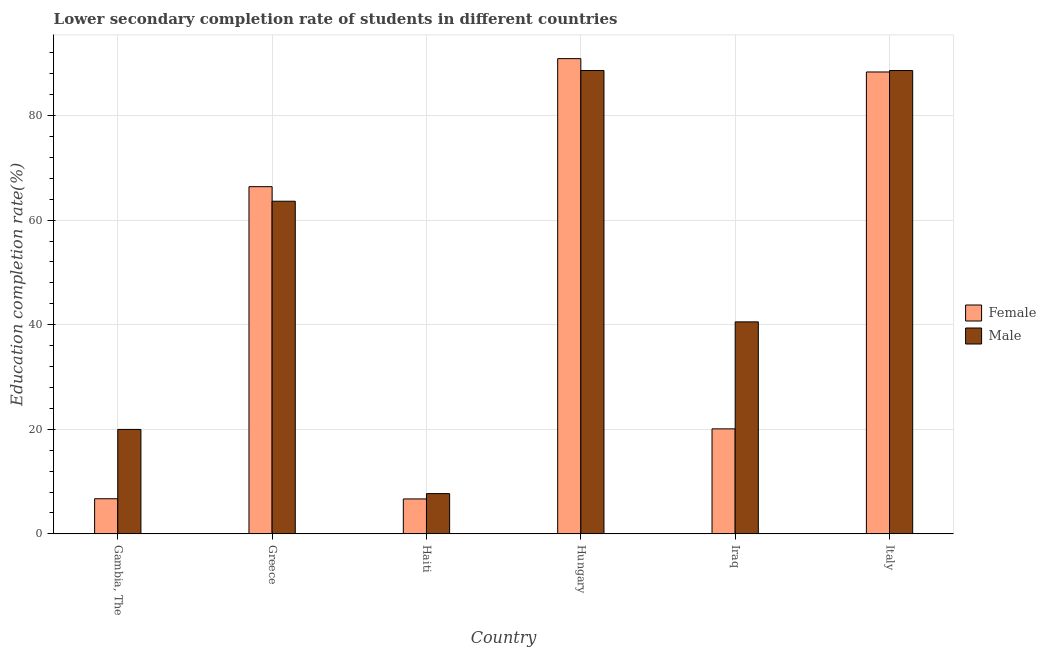Are the number of bars per tick equal to the number of legend labels?
Provide a short and direct response. Yes. How many bars are there on the 4th tick from the left?
Offer a terse response. 2. How many bars are there on the 6th tick from the right?
Provide a short and direct response. 2. What is the label of the 6th group of bars from the left?
Make the answer very short. Italy. In how many cases, is the number of bars for a given country not equal to the number of legend labels?
Make the answer very short. 0. What is the education completion rate of male students in Haiti?
Keep it short and to the point. 7.7. Across all countries, what is the maximum education completion rate of male students?
Offer a terse response. 88.61. Across all countries, what is the minimum education completion rate of female students?
Provide a short and direct response. 6.68. In which country was the education completion rate of male students maximum?
Your response must be concise. Hungary. In which country was the education completion rate of male students minimum?
Make the answer very short. Haiti. What is the total education completion rate of female students in the graph?
Offer a terse response. 279.1. What is the difference between the education completion rate of male students in Iraq and that in Italy?
Your answer should be compact. -48.07. What is the difference between the education completion rate of female students in Haiti and the education completion rate of male students in Gambia, The?
Provide a succinct answer. -13.29. What is the average education completion rate of male students per country?
Give a very brief answer. 51.51. What is the difference between the education completion rate of male students and education completion rate of female students in Gambia, The?
Provide a succinct answer. 13.25. What is the ratio of the education completion rate of female students in Gambia, The to that in Haiti?
Offer a terse response. 1.01. Is the education completion rate of male students in Haiti less than that in Iraq?
Your answer should be very brief. Yes. Is the difference between the education completion rate of female students in Greece and Iraq greater than the difference between the education completion rate of male students in Greece and Iraq?
Provide a succinct answer. Yes. What is the difference between the highest and the second highest education completion rate of male students?
Provide a succinct answer. 0. What is the difference between the highest and the lowest education completion rate of female students?
Give a very brief answer. 84.2. In how many countries, is the education completion rate of male students greater than the average education completion rate of male students taken over all countries?
Your answer should be compact. 3. How many bars are there?
Make the answer very short. 12. Are all the bars in the graph horizontal?
Ensure brevity in your answer.  No. How many countries are there in the graph?
Keep it short and to the point. 6. What is the difference between two consecutive major ticks on the Y-axis?
Your response must be concise. 20. Are the values on the major ticks of Y-axis written in scientific E-notation?
Your answer should be very brief. No. Where does the legend appear in the graph?
Offer a terse response. Center right. How many legend labels are there?
Your response must be concise. 2. How are the legend labels stacked?
Offer a very short reply. Vertical. What is the title of the graph?
Provide a short and direct response. Lower secondary completion rate of students in different countries. What is the label or title of the X-axis?
Give a very brief answer. Country. What is the label or title of the Y-axis?
Ensure brevity in your answer.  Education completion rate(%). What is the Education completion rate(%) of Female in Gambia, The?
Ensure brevity in your answer.  6.72. What is the Education completion rate(%) in Male in Gambia, The?
Give a very brief answer. 19.97. What is the Education completion rate(%) of Female in Greece?
Keep it short and to the point. 66.4. What is the Education completion rate(%) of Male in Greece?
Your answer should be compact. 63.61. What is the Education completion rate(%) in Female in Haiti?
Provide a succinct answer. 6.68. What is the Education completion rate(%) of Male in Haiti?
Keep it short and to the point. 7.7. What is the Education completion rate(%) of Female in Hungary?
Ensure brevity in your answer.  90.88. What is the Education completion rate(%) in Male in Hungary?
Provide a short and direct response. 88.61. What is the Education completion rate(%) of Female in Iraq?
Make the answer very short. 20.08. What is the Education completion rate(%) in Male in Iraq?
Offer a terse response. 40.54. What is the Education completion rate(%) in Female in Italy?
Offer a terse response. 88.33. What is the Education completion rate(%) in Male in Italy?
Give a very brief answer. 88.61. Across all countries, what is the maximum Education completion rate(%) in Female?
Your answer should be compact. 90.88. Across all countries, what is the maximum Education completion rate(%) in Male?
Make the answer very short. 88.61. Across all countries, what is the minimum Education completion rate(%) of Female?
Give a very brief answer. 6.68. Across all countries, what is the minimum Education completion rate(%) in Male?
Offer a very short reply. 7.7. What is the total Education completion rate(%) in Female in the graph?
Give a very brief answer. 279.1. What is the total Education completion rate(%) of Male in the graph?
Ensure brevity in your answer.  309.04. What is the difference between the Education completion rate(%) in Female in Gambia, The and that in Greece?
Make the answer very short. -59.68. What is the difference between the Education completion rate(%) in Male in Gambia, The and that in Greece?
Your answer should be compact. -43.64. What is the difference between the Education completion rate(%) in Female in Gambia, The and that in Haiti?
Your response must be concise. 0.04. What is the difference between the Education completion rate(%) in Male in Gambia, The and that in Haiti?
Ensure brevity in your answer.  12.28. What is the difference between the Education completion rate(%) in Female in Gambia, The and that in Hungary?
Keep it short and to the point. -84.17. What is the difference between the Education completion rate(%) of Male in Gambia, The and that in Hungary?
Make the answer very short. -68.64. What is the difference between the Education completion rate(%) in Female in Gambia, The and that in Iraq?
Provide a succinct answer. -13.36. What is the difference between the Education completion rate(%) of Male in Gambia, The and that in Iraq?
Keep it short and to the point. -20.57. What is the difference between the Education completion rate(%) in Female in Gambia, The and that in Italy?
Your response must be concise. -81.62. What is the difference between the Education completion rate(%) in Male in Gambia, The and that in Italy?
Offer a very short reply. -68.64. What is the difference between the Education completion rate(%) of Female in Greece and that in Haiti?
Offer a very short reply. 59.72. What is the difference between the Education completion rate(%) in Male in Greece and that in Haiti?
Provide a succinct answer. 55.92. What is the difference between the Education completion rate(%) of Female in Greece and that in Hungary?
Make the answer very short. -24.48. What is the difference between the Education completion rate(%) of Male in Greece and that in Hungary?
Provide a succinct answer. -25. What is the difference between the Education completion rate(%) in Female in Greece and that in Iraq?
Keep it short and to the point. 46.32. What is the difference between the Education completion rate(%) in Male in Greece and that in Iraq?
Give a very brief answer. 23.07. What is the difference between the Education completion rate(%) in Female in Greece and that in Italy?
Your response must be concise. -21.93. What is the difference between the Education completion rate(%) in Male in Greece and that in Italy?
Give a very brief answer. -24.99. What is the difference between the Education completion rate(%) in Female in Haiti and that in Hungary?
Offer a terse response. -84.2. What is the difference between the Education completion rate(%) in Male in Haiti and that in Hungary?
Your answer should be very brief. -80.92. What is the difference between the Education completion rate(%) in Female in Haiti and that in Iraq?
Provide a succinct answer. -13.4. What is the difference between the Education completion rate(%) of Male in Haiti and that in Iraq?
Provide a succinct answer. -32.85. What is the difference between the Education completion rate(%) of Female in Haiti and that in Italy?
Offer a very short reply. -81.65. What is the difference between the Education completion rate(%) of Male in Haiti and that in Italy?
Your answer should be compact. -80.91. What is the difference between the Education completion rate(%) in Female in Hungary and that in Iraq?
Make the answer very short. 70.8. What is the difference between the Education completion rate(%) in Male in Hungary and that in Iraq?
Your response must be concise. 48.07. What is the difference between the Education completion rate(%) of Female in Hungary and that in Italy?
Ensure brevity in your answer.  2.55. What is the difference between the Education completion rate(%) of Male in Hungary and that in Italy?
Provide a short and direct response. 0. What is the difference between the Education completion rate(%) of Female in Iraq and that in Italy?
Provide a succinct answer. -68.25. What is the difference between the Education completion rate(%) of Male in Iraq and that in Italy?
Provide a short and direct response. -48.07. What is the difference between the Education completion rate(%) of Female in Gambia, The and the Education completion rate(%) of Male in Greece?
Ensure brevity in your answer.  -56.9. What is the difference between the Education completion rate(%) in Female in Gambia, The and the Education completion rate(%) in Male in Haiti?
Ensure brevity in your answer.  -0.98. What is the difference between the Education completion rate(%) of Female in Gambia, The and the Education completion rate(%) of Male in Hungary?
Keep it short and to the point. -81.89. What is the difference between the Education completion rate(%) of Female in Gambia, The and the Education completion rate(%) of Male in Iraq?
Your response must be concise. -33.82. What is the difference between the Education completion rate(%) of Female in Gambia, The and the Education completion rate(%) of Male in Italy?
Ensure brevity in your answer.  -81.89. What is the difference between the Education completion rate(%) of Female in Greece and the Education completion rate(%) of Male in Haiti?
Provide a short and direct response. 58.7. What is the difference between the Education completion rate(%) in Female in Greece and the Education completion rate(%) in Male in Hungary?
Offer a very short reply. -22.21. What is the difference between the Education completion rate(%) of Female in Greece and the Education completion rate(%) of Male in Iraq?
Provide a succinct answer. 25.86. What is the difference between the Education completion rate(%) of Female in Greece and the Education completion rate(%) of Male in Italy?
Offer a terse response. -22.21. What is the difference between the Education completion rate(%) of Female in Haiti and the Education completion rate(%) of Male in Hungary?
Ensure brevity in your answer.  -81.93. What is the difference between the Education completion rate(%) of Female in Haiti and the Education completion rate(%) of Male in Iraq?
Ensure brevity in your answer.  -33.86. What is the difference between the Education completion rate(%) of Female in Haiti and the Education completion rate(%) of Male in Italy?
Your response must be concise. -81.93. What is the difference between the Education completion rate(%) of Female in Hungary and the Education completion rate(%) of Male in Iraq?
Offer a very short reply. 50.34. What is the difference between the Education completion rate(%) in Female in Hungary and the Education completion rate(%) in Male in Italy?
Provide a short and direct response. 2.28. What is the difference between the Education completion rate(%) of Female in Iraq and the Education completion rate(%) of Male in Italy?
Offer a very short reply. -68.53. What is the average Education completion rate(%) in Female per country?
Your response must be concise. 46.52. What is the average Education completion rate(%) of Male per country?
Offer a terse response. 51.51. What is the difference between the Education completion rate(%) of Female and Education completion rate(%) of Male in Gambia, The?
Offer a very short reply. -13.25. What is the difference between the Education completion rate(%) of Female and Education completion rate(%) of Male in Greece?
Your answer should be compact. 2.78. What is the difference between the Education completion rate(%) of Female and Education completion rate(%) of Male in Haiti?
Make the answer very short. -1.02. What is the difference between the Education completion rate(%) in Female and Education completion rate(%) in Male in Hungary?
Ensure brevity in your answer.  2.27. What is the difference between the Education completion rate(%) in Female and Education completion rate(%) in Male in Iraq?
Give a very brief answer. -20.46. What is the difference between the Education completion rate(%) in Female and Education completion rate(%) in Male in Italy?
Keep it short and to the point. -0.28. What is the ratio of the Education completion rate(%) of Female in Gambia, The to that in Greece?
Keep it short and to the point. 0.1. What is the ratio of the Education completion rate(%) of Male in Gambia, The to that in Greece?
Provide a short and direct response. 0.31. What is the ratio of the Education completion rate(%) in Female in Gambia, The to that in Haiti?
Keep it short and to the point. 1.01. What is the ratio of the Education completion rate(%) in Male in Gambia, The to that in Haiti?
Keep it short and to the point. 2.6. What is the ratio of the Education completion rate(%) of Female in Gambia, The to that in Hungary?
Make the answer very short. 0.07. What is the ratio of the Education completion rate(%) in Male in Gambia, The to that in Hungary?
Offer a terse response. 0.23. What is the ratio of the Education completion rate(%) in Female in Gambia, The to that in Iraq?
Provide a succinct answer. 0.33. What is the ratio of the Education completion rate(%) in Male in Gambia, The to that in Iraq?
Provide a short and direct response. 0.49. What is the ratio of the Education completion rate(%) in Female in Gambia, The to that in Italy?
Keep it short and to the point. 0.08. What is the ratio of the Education completion rate(%) of Male in Gambia, The to that in Italy?
Your answer should be compact. 0.23. What is the ratio of the Education completion rate(%) of Female in Greece to that in Haiti?
Give a very brief answer. 9.94. What is the ratio of the Education completion rate(%) of Male in Greece to that in Haiti?
Ensure brevity in your answer.  8.27. What is the ratio of the Education completion rate(%) of Female in Greece to that in Hungary?
Provide a short and direct response. 0.73. What is the ratio of the Education completion rate(%) in Male in Greece to that in Hungary?
Offer a very short reply. 0.72. What is the ratio of the Education completion rate(%) in Female in Greece to that in Iraq?
Provide a succinct answer. 3.31. What is the ratio of the Education completion rate(%) of Male in Greece to that in Iraq?
Your answer should be compact. 1.57. What is the ratio of the Education completion rate(%) in Female in Greece to that in Italy?
Make the answer very short. 0.75. What is the ratio of the Education completion rate(%) of Male in Greece to that in Italy?
Keep it short and to the point. 0.72. What is the ratio of the Education completion rate(%) of Female in Haiti to that in Hungary?
Offer a very short reply. 0.07. What is the ratio of the Education completion rate(%) of Male in Haiti to that in Hungary?
Give a very brief answer. 0.09. What is the ratio of the Education completion rate(%) in Female in Haiti to that in Iraq?
Make the answer very short. 0.33. What is the ratio of the Education completion rate(%) in Male in Haiti to that in Iraq?
Offer a very short reply. 0.19. What is the ratio of the Education completion rate(%) of Female in Haiti to that in Italy?
Give a very brief answer. 0.08. What is the ratio of the Education completion rate(%) in Male in Haiti to that in Italy?
Ensure brevity in your answer.  0.09. What is the ratio of the Education completion rate(%) of Female in Hungary to that in Iraq?
Provide a succinct answer. 4.53. What is the ratio of the Education completion rate(%) in Male in Hungary to that in Iraq?
Your answer should be very brief. 2.19. What is the ratio of the Education completion rate(%) in Female in Hungary to that in Italy?
Offer a terse response. 1.03. What is the ratio of the Education completion rate(%) in Male in Hungary to that in Italy?
Keep it short and to the point. 1. What is the ratio of the Education completion rate(%) of Female in Iraq to that in Italy?
Make the answer very short. 0.23. What is the ratio of the Education completion rate(%) of Male in Iraq to that in Italy?
Offer a terse response. 0.46. What is the difference between the highest and the second highest Education completion rate(%) of Female?
Offer a very short reply. 2.55. What is the difference between the highest and the second highest Education completion rate(%) in Male?
Your answer should be very brief. 0. What is the difference between the highest and the lowest Education completion rate(%) of Female?
Your answer should be compact. 84.2. What is the difference between the highest and the lowest Education completion rate(%) of Male?
Offer a terse response. 80.92. 